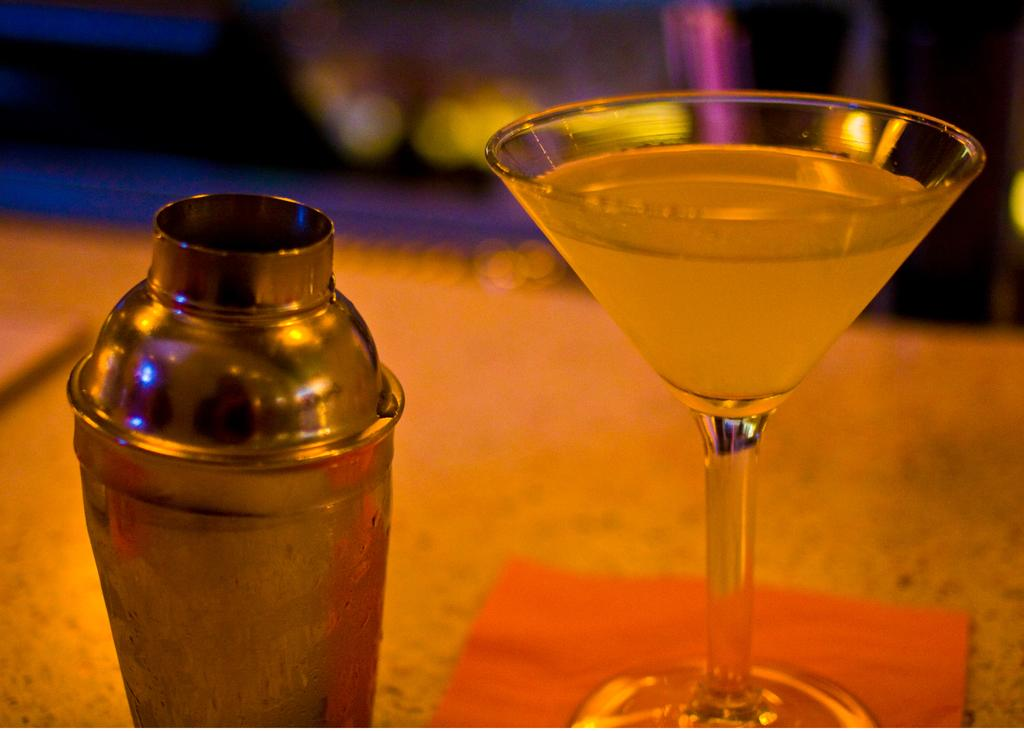What piece of furniture is present in the image? There is a table in the image. What is placed on the table? There is a glass and a bottle on the table. Can you describe the background of the image? The background of the image is blurred. What type of curtain is hanging near the table in the image? There is no curtain present in the image. Can you tell me how many pencils are on the table in the image? There are no pencils visible in the image; only a glass and a bottle are present on the table. 